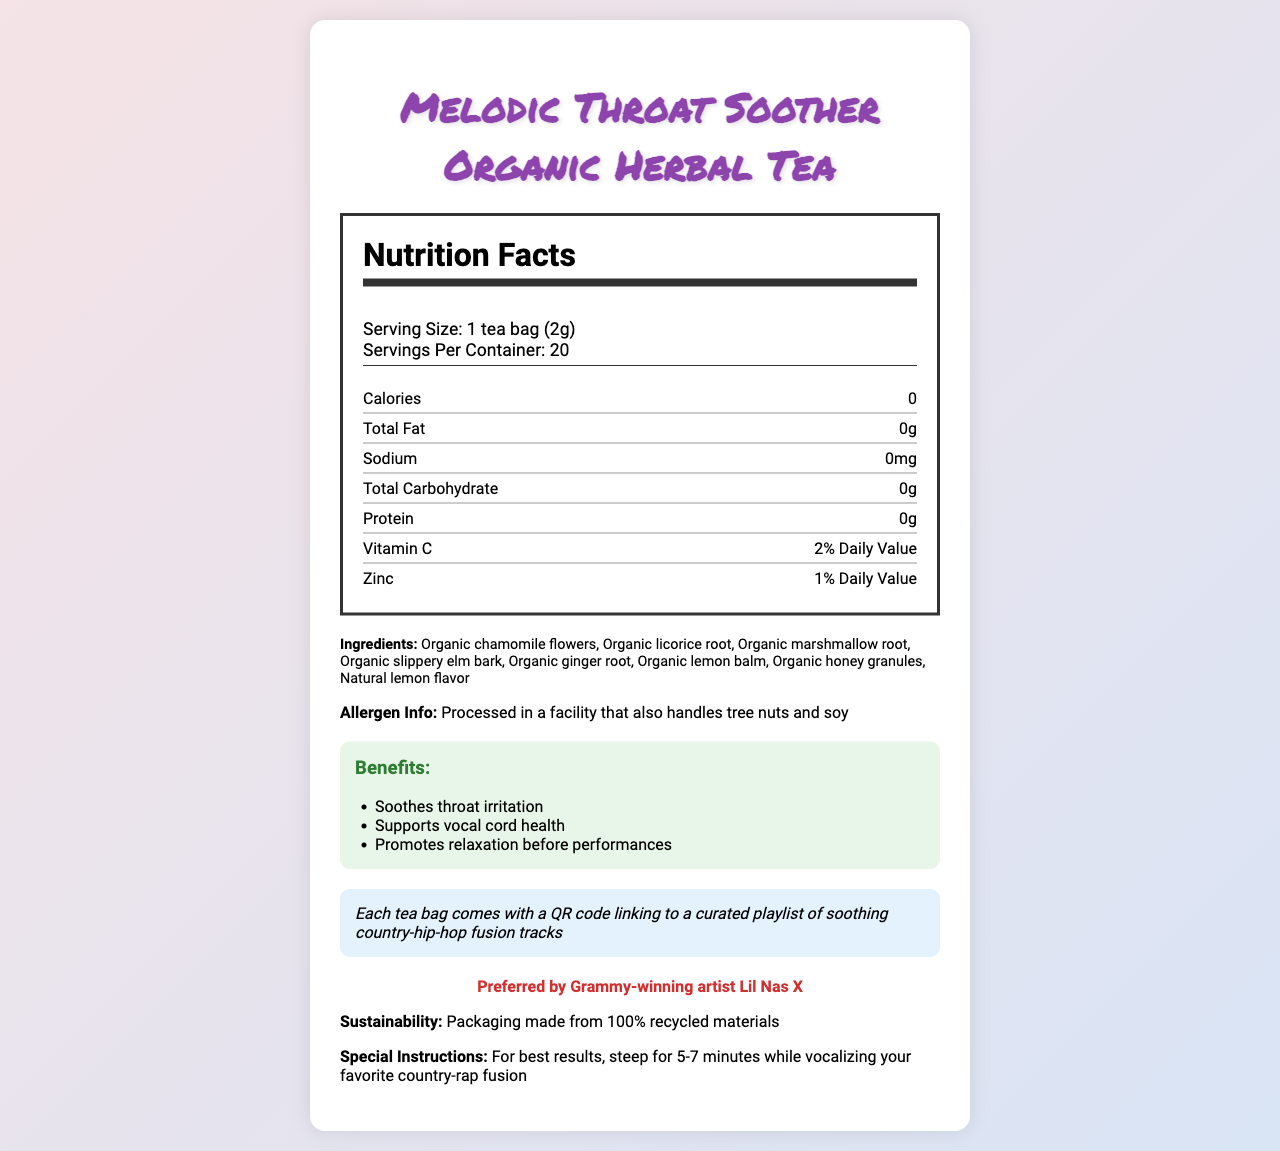what is the serving size for Melodic Throat Soother Organic Herbal Tea? The serving size is specified in the serving info section under Nutrition Facts.
Answer: 1 tea bag (2g) how many servings are there per container? The servings per container are mentioned next to the serving size in the Nutrition Facts section.
Answer: 20 how many calories are in one serving? The calories per serving are listed in the nutrient row under Nutrition Facts.
Answer: 0 what percentage of the Daily Value of Vitamin C is provided per serving? This information is listed in the nutrient row under Vitamin C in the Nutrition Facts section.
Answer: 2% Daily Value is any protein contained in this herbal tea? The protein content is listed as 0g in the Nutrition Facts section.
Answer: No which ingredients are included in Melodic Throat Soother Organic Herbal Tea? The ingredients are listed in the ingredients section of the document.
Answer: Organic chamomile flowers, Organic licorice root, Organic marshmallow root, Organic slippery elm bark, Organic ginger root, Organic lemon balm, Organic honey granules, Natural lemon flavor are there any allergens to be aware of? The allergen information is provided in a dedicated section below the ingredients.
Answer: Processed in a facility that also handles tree nuts and soy which music-inspired blends are mentioned in the document? These blends are mentioned in the description of the tea.
Answer: Nashville Nightingale Mix, Rap-sody Remedy True/False: The packaging of this product is made from recycled materials. The sustainability section mentions that the packaging is made from 100% recycled materials.
Answer: True which celebrity endorses Melodic Throat Soother Organic Herbal Tea? The celebrity endorsement section states that it is preferred by Grammy-winning artist Lil Nas X.
Answer: Lil Nas X how long should you steep the tea for best results? The special instructions part states to steep the tea for 5-7 minutes.
Answer: 5-7 minutes which of the following is not an ingredient in Melodic Throat Soother Organic Herbal Tea?
A. Organic chamomile flowers
B. Organic ginger root
C. Organic peppermint leaves
D. Natural lemon flavor The ingredients list does not mention Organic peppermint leaves.
Answer: C. Organic peppermint leaves which of the following benefits is not associated with this tea?
I. Soothes throat irritation
II. Supports vocal cord health
III. Aids in digestion
IV. Promotes relaxation before performances The benefits listed are for throat irritation, vocal cord health, and pre-performance relaxation.
Answer: III. Aids in digestion can you scan a QR code to access a curated playlist? The music note section mentions that each tea bag has a QR code linking to a curated playlist of soothing country-hip-hop fusion tracks.
Answer: Yes summarize the main idea of the document. The document highlights the nutritional aspects, ingredients, usage instructions, and special features like sustainability, music blends, and celebrity endorsement of the herbal tea.
Answer: The document provides information about Melodic Throat Soother Organic Herbal Tea, including its nutrition facts, ingredients, benefits, allergen info, and unique features like music-inspired blends, celebrity endorsement, and a QR code for a curated playlist. what is the price of Melodic Throat Soother Organic Herbal Tea? The document does not provide any information about the price of the tea.
Answer: Cannot be determined 